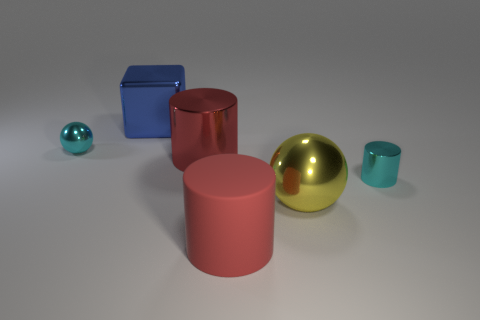Subtract all red matte cylinders. How many cylinders are left? 2 Subtract all gray spheres. How many red cylinders are left? 2 Add 3 large cubes. How many objects exist? 9 Subtract all cubes. How many objects are left? 5 Add 1 blue things. How many blue things exist? 2 Subtract 1 yellow spheres. How many objects are left? 5 Subtract all brown balls. Subtract all yellow metal objects. How many objects are left? 5 Add 4 tiny cyan metal balls. How many tiny cyan metal balls are left? 5 